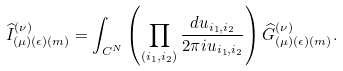Convert formula to latex. <formula><loc_0><loc_0><loc_500><loc_500>\widehat { I } _ { ( \mu ) ( \epsilon ) ( m ) } ^ { ( \nu ) } = \int _ { C ^ { N } } \left ( \prod _ { ( i _ { 1 } , i _ { 2 } ) } \frac { d u _ { i _ { 1 } , i _ { 2 } } } { 2 \pi i u _ { i _ { 1 } , i _ { 2 } } } \right ) \widehat { G } _ { ( \mu ) ( \epsilon ) ( m ) } ^ { ( \nu ) } .</formula> 